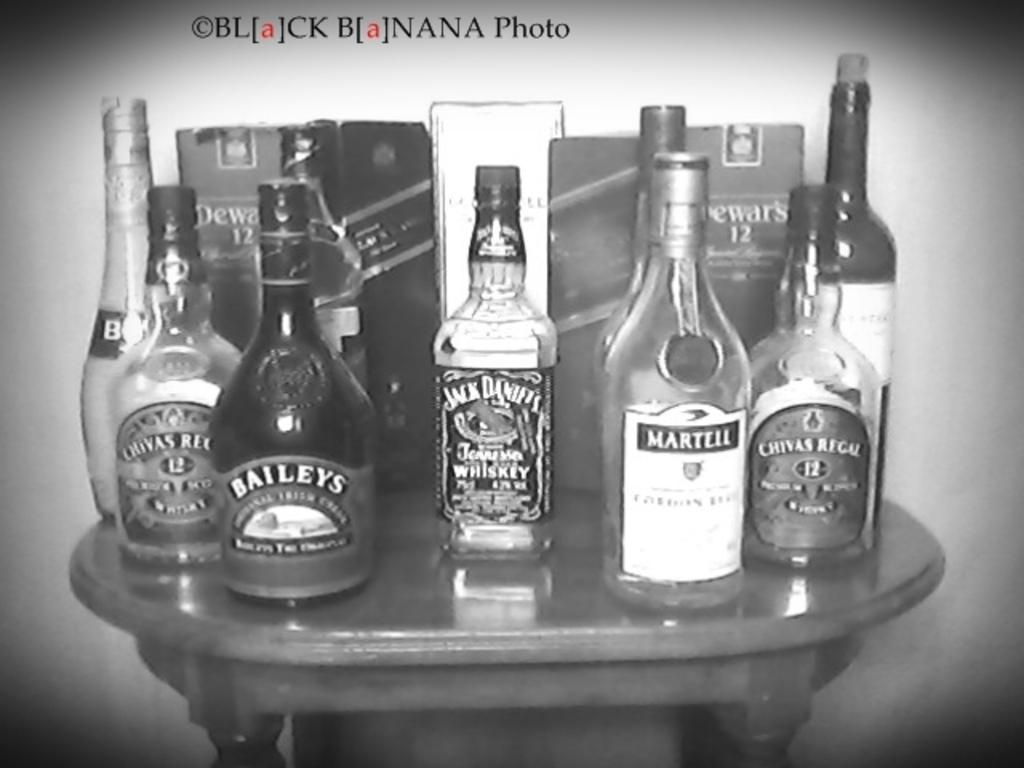<image>
Relay a brief, clear account of the picture shown. Bottles of liquor are arranged on a small table, Jack Daniels in the center. 